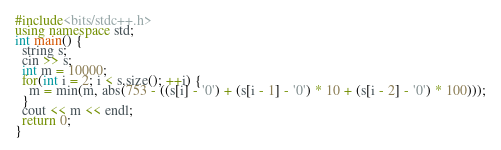Convert code to text. <code><loc_0><loc_0><loc_500><loc_500><_C++_>#include<bits/stdc++.h>
using namespace std;
int main() {
  string s;
  cin >> s;
  int m = 10000;
  for(int i = 2; i < s.size(); ++i) {
    m = min(m, abs(753 - ((s[i] - '0') + (s[i - 1] - '0') * 10 + (s[i - 2] - '0') * 100)));
  }
  cout << m << endl;
  return 0;
}</code> 